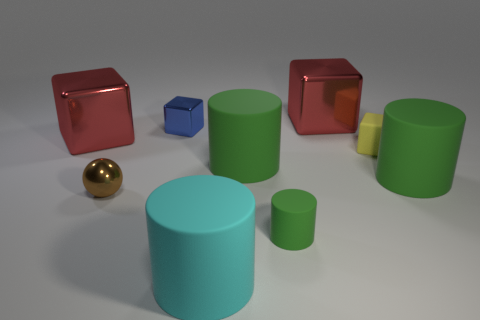Subtract all green cylinders. How many were subtracted if there are1green cylinders left? 2 Subtract all small matte cylinders. How many cylinders are left? 3 Subtract all green balls. How many green cylinders are left? 3 Add 1 big cyan cubes. How many objects exist? 10 Subtract 2 cylinders. How many cylinders are left? 2 Subtract all cyan cylinders. How many cylinders are left? 3 Subtract all spheres. How many objects are left? 8 Subtract all blue cylinders. Subtract all green cubes. How many cylinders are left? 4 Add 4 brown balls. How many brown balls exist? 5 Subtract 0 green blocks. How many objects are left? 9 